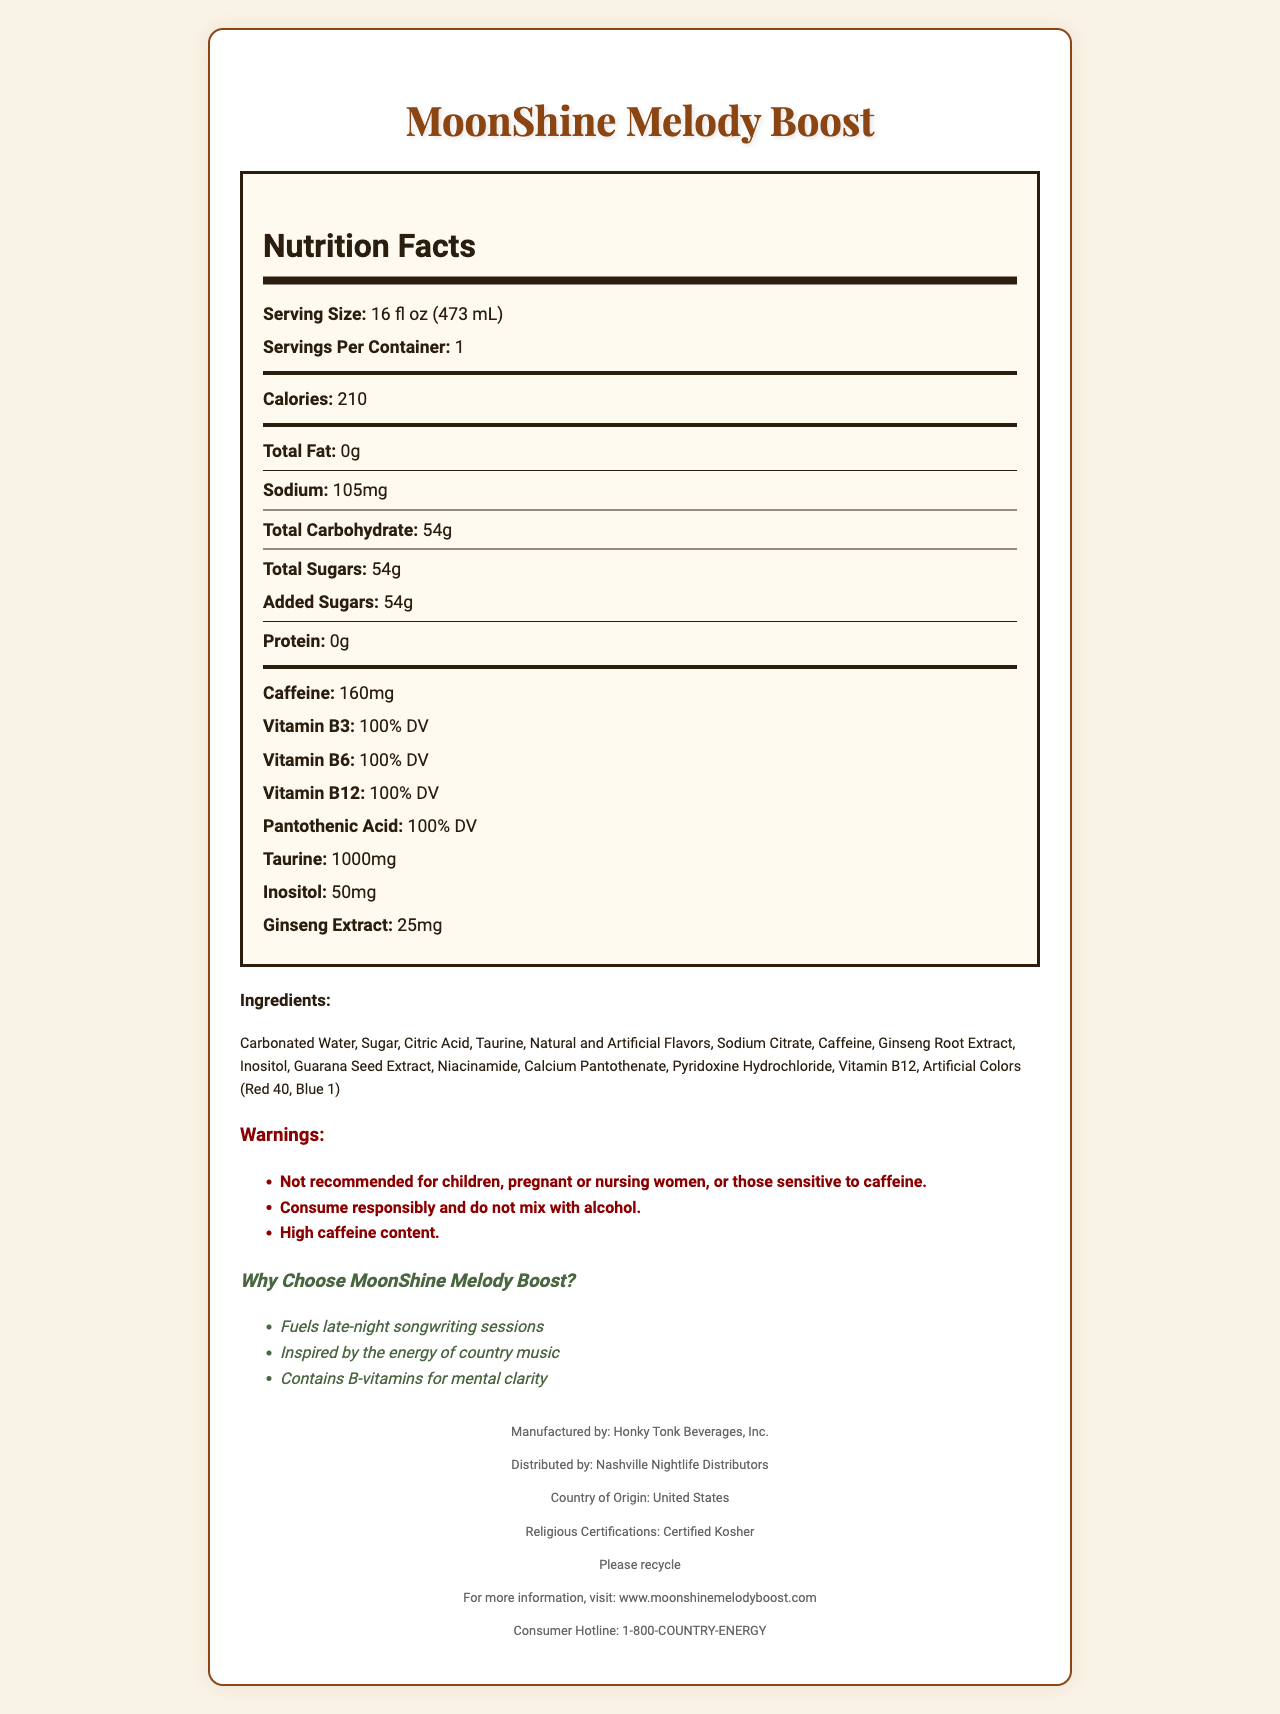What is the serving size of MoonShine Melody Boost? The serving size is clearly listed as "16 fl oz (473 mL)" in the "Nutrition Facts" section.
Answer: 16 fl oz (473 mL) How many calories are there in one serving of MoonShine Melody Boost? The document states that there are 210 calories per serving.
Answer: 210 What is the amount of caffeine in MoonShine Melody Boost? The amount of caffeine is specified to be 160mg in the "Nutrition Facts" section.
Answer: 160mg Which vitamins are present in MoonShine Melody Boost at 100% Daily Value? The "Nutrition Facts" section lists these vitamins, each with 100% Daily Value.
Answer: Vitamin B3, Vitamin B6, Vitamin B12, Pantothenic Acid What is the total carbohydrate content in MoonShine Melody Boost? The total carbohydrate content is listed as 54g in the "Nutrition Facts" section.
Answer: 54g Which ingredients are included in MoonShine Melody Boost? A. Carbonated Water, Sugar, Citric Acid B. Sodium Citrate, Caffeine, Ginseng Root Extract C. Inositol, Guarana Seed Extract, Niacinamide D. All of the above All the listed ingredients are mentioned in the "Ingredients" section.
Answer: D Who is the manufacturer of MoonShine Melody Boost? A. Honky Tonk Beverages, Inc. B. Nashville Nightlife Distributors C. Country Music Energy Co. "Honky Tonk Beverages, Inc." is mentioned as the manufacturer in the footer section of the document.
Answer: A Is MoonShine Melody Boost recommended for children? The document clearly warns that it is "Not recommended for children."
Answer: No What is the distribution company for MoonShine Melody Boost? The "Distributed by" section lists "Nashville Nightlife Distributors."
Answer: Nashville Nightlife Distributors Describe the main idea of MoonShine Melody Boost's document. The document provides a comprehensive overview of MoonShine Melody Boost, including its nutritional facts, ingredients, marketing claims, manufacturer details, and warnings. It emphasizes the product's suitability for late-night energy and mental clarity with high B-vitamins and caffeine content.
Answer: MoonShine Melody Boost is an energy drink designed to fuel late-night songwriting sessions, inspired by country music. It provides detailed nutritional information, including high caffeine content, multiple B-vitamins, taurine, and other ingredients. The product has warnings and marketing claims, is certified kosher, and produced in the USA. Recycling info, website, and consumer hotline are also provided. Does MoonShine Melody Boost contain protein? The "Nutrition Facts" section states that the protein content is "0g."
Answer: No Can MoonShine Melody Boost be consumed with alcohol? The warnings section states, "Consume responsibly and do not mix with alcohol."
Answer: No What certifications does MoonShine Melody Boost have? The document lists "Certified Kosher" under religious certifications.
Answer: Certified Kosher How much taurine is in MoonShine Melody Boost? The amount of taurine is specified as 1000mg in the "Nutrition Facts" section.
Answer: 1000mg What is the level of sugar added in MoonShine Melody Boost? The document indicates that the total and added sugars are both 54g.
Answer: 54g What is the recycling information provided for the product? The footer section includes the statement "Please recycle."
Answer: Please recycle Explain the allergen information for MoonShine Melody Boost. The allergen information states that it is "Produced in a facility that also processes milk, soy, and tree nuts."
Answer: Produced in a facility that also processes milk, soy, and tree nuts What is the purpose of MoonShine Melody Boost according to its marketing claims? The marketing claims include "Fuels late-night songwriting sessions" as one of the main purposes of the product.
Answer: Fuels late-night songwriting sessions What is the website for more information about MoonShine Melody Boost? The footer lists the website as www.moonshinemelodyboost.com.
Answer: www.moonshinemelodyboost.com What is the consumer hotline number for MoonShine Melody Boost? The footer provides the consumer hotline number as 1-800-COUNTRY-ENERGY.
Answer: 1-800-COUNTRY-ENERGY What is the vitamin content of MoonShine Melody Boost? The document lists several vitamins (B3, B6, B12, Pantothenic Acid) at 100% Daily Value but does not provide exact amounts in milligrams or micrograms, only as a percentage of Daily Value.
Answer: Cannot be determined 